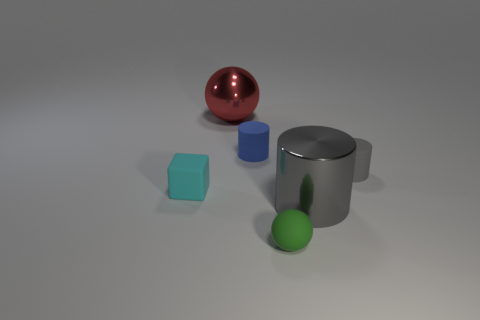Is the material of the small green sphere the same as the tiny gray cylinder?
Your response must be concise. Yes. The rubber object that is the same color as the big cylinder is what shape?
Ensure brevity in your answer.  Cylinder. Is the color of the large metallic object in front of the small cyan object the same as the matte ball?
Provide a short and direct response. No. How many large cylinders are behind the small rubber cylinder on the right side of the gray metal cylinder?
Provide a succinct answer. 0. There is a rubber block that is the same size as the blue rubber cylinder; what color is it?
Offer a very short reply. Cyan. There is a ball to the right of the small blue matte cylinder; what is its material?
Make the answer very short. Rubber. What is the tiny object that is both left of the tiny green matte object and in front of the tiny blue cylinder made of?
Offer a very short reply. Rubber. Is the size of the gray thing that is in front of the cyan rubber block the same as the tiny blue matte object?
Keep it short and to the point. No. There is a gray shiny object; what shape is it?
Your answer should be very brief. Cylinder. What number of blue objects are the same shape as the gray rubber object?
Offer a terse response. 1. 